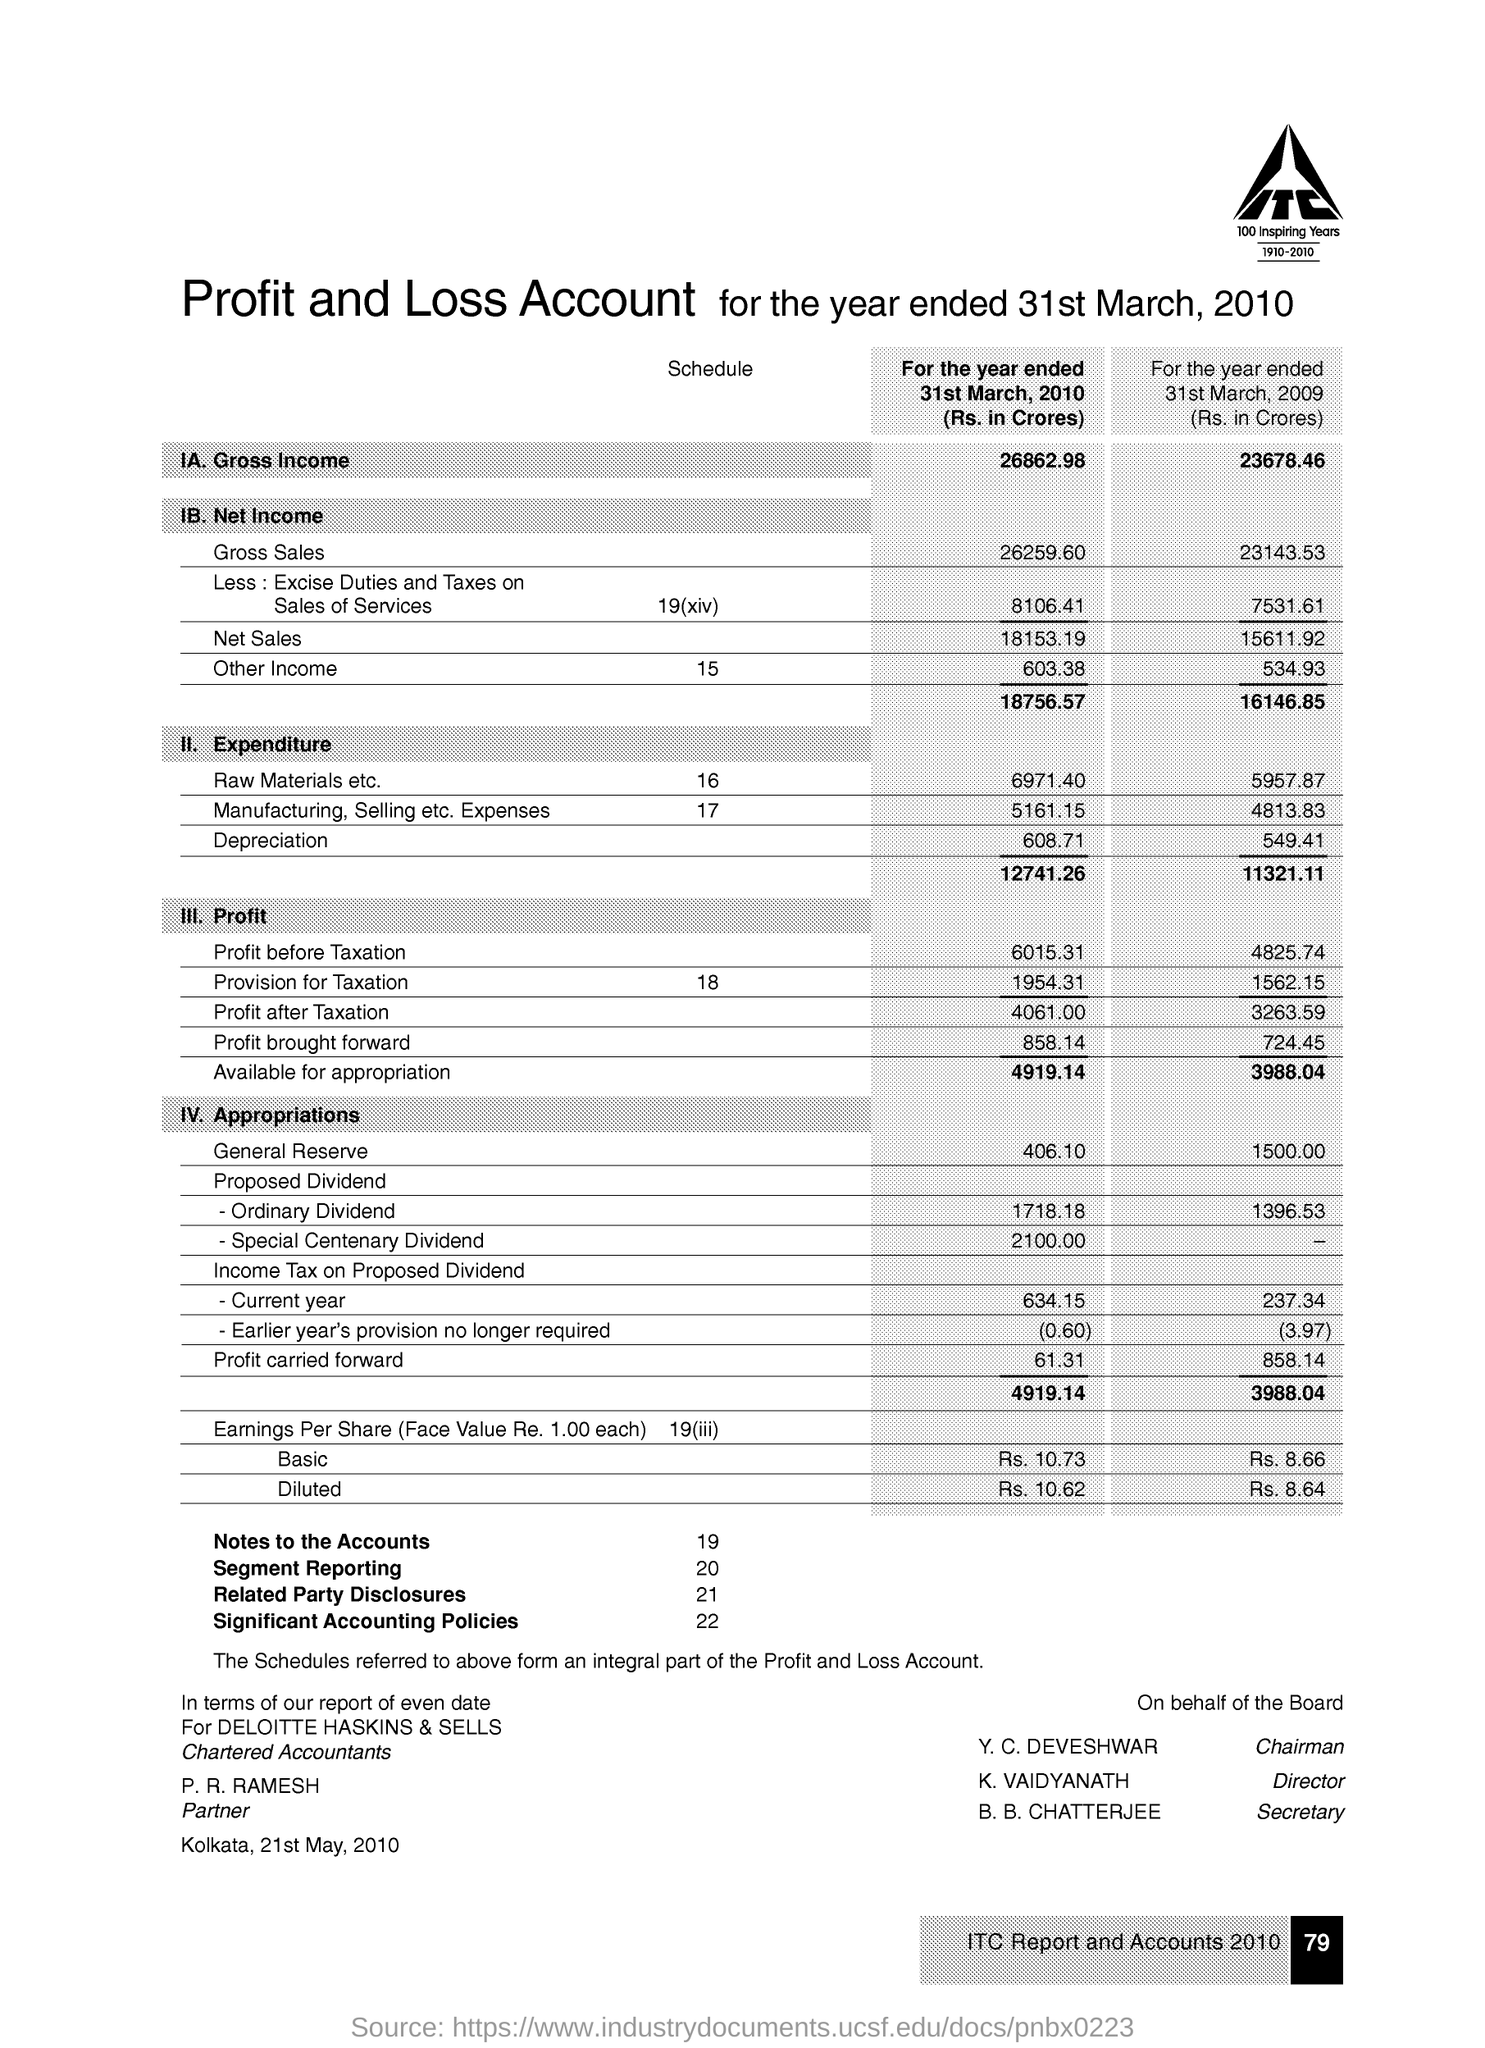Identify some key points in this picture. Segment reporting is a method of organizing financial information for a company based on specific criteria, such as product lines or geographic regions. The number of segments used can vary depending on the company's structure and operations. There are 21 related party disclosures in the given text. There are 19 notes to the accounts. There are 22 significant accounting policies. 